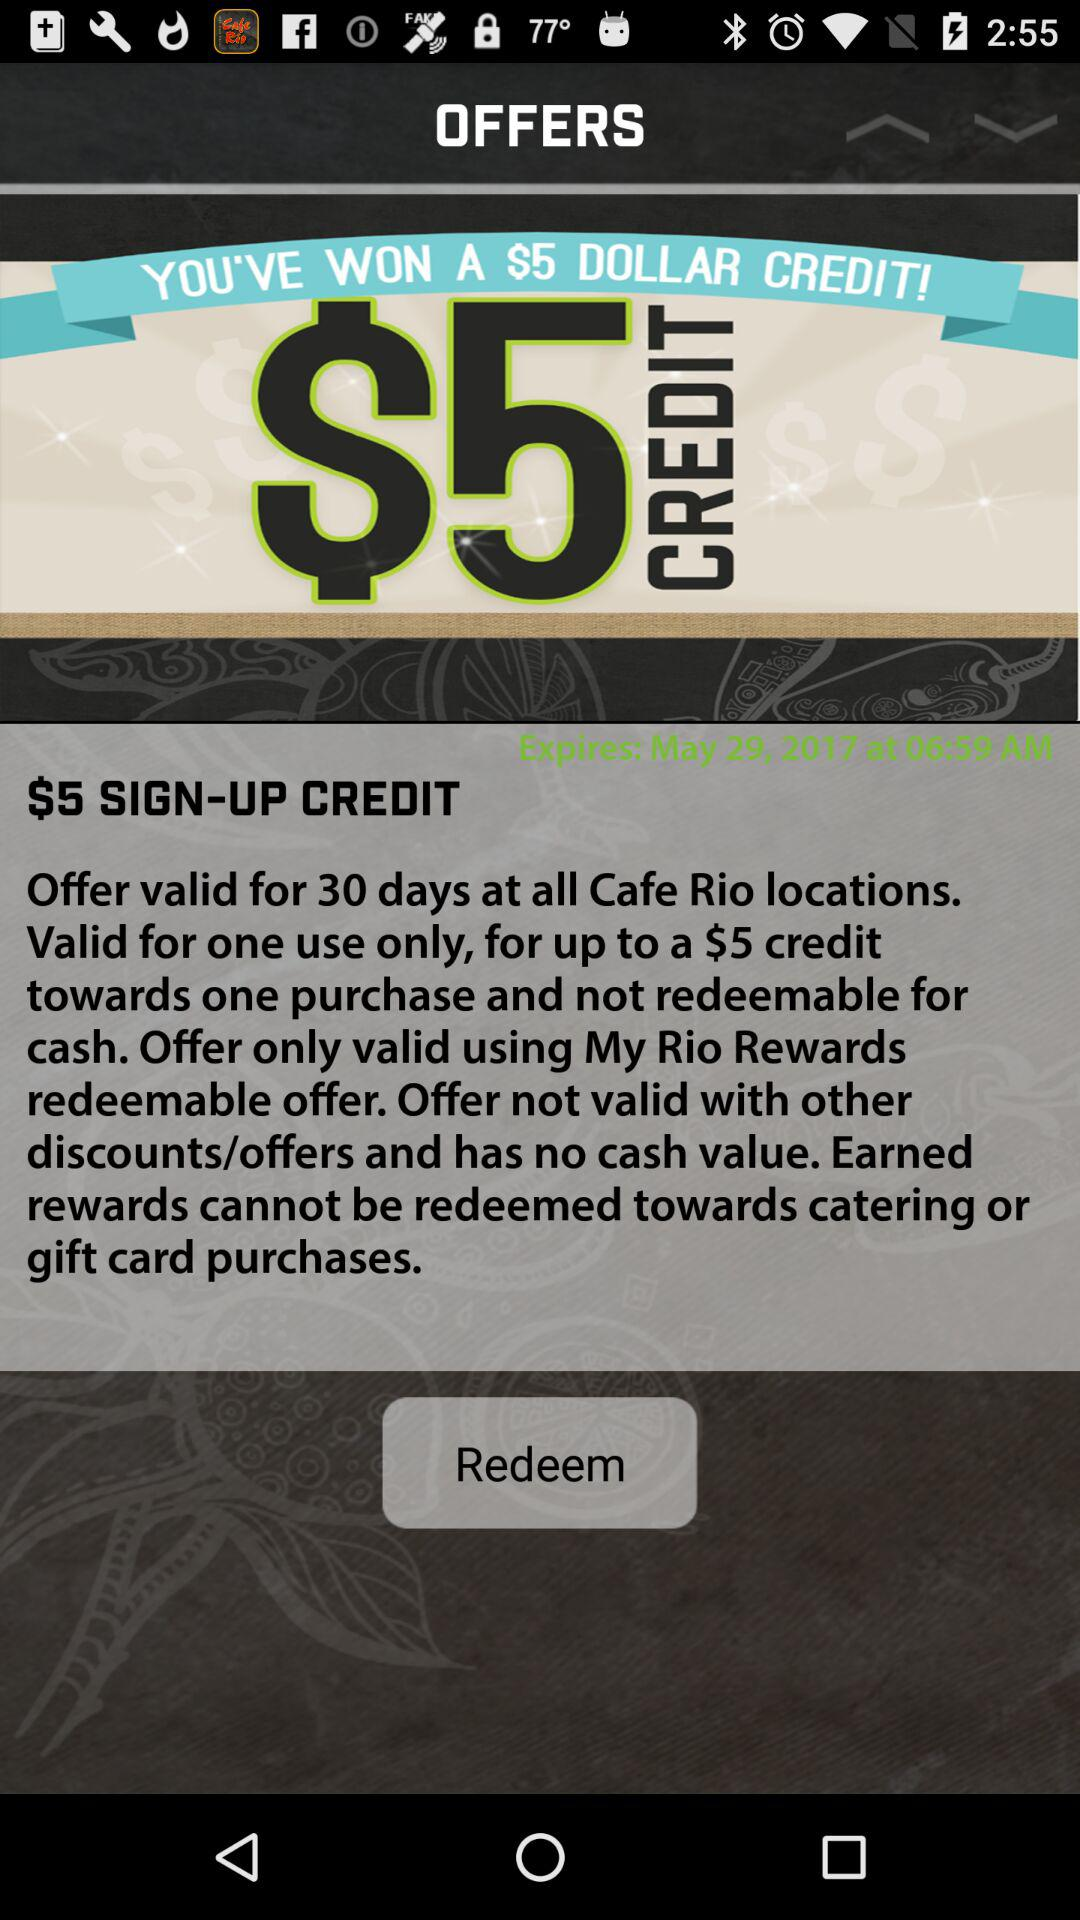How much is the offer worth?
Answer the question using a single word or phrase. $5 